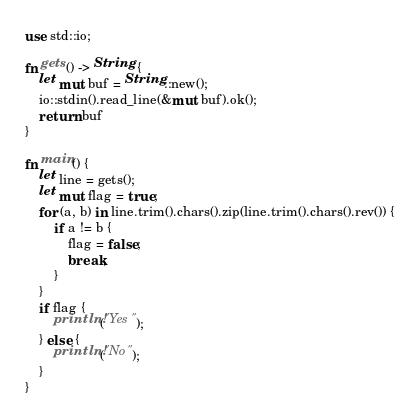<code> <loc_0><loc_0><loc_500><loc_500><_Rust_>use std::io;

fn gets() -> String {
    let mut buf = String::new();
    io::stdin().read_line(&mut buf).ok();
    return buf
}

fn main() {
    let line = gets();
    let mut flag = true;
    for (a, b) in line.trim().chars().zip(line.trim().chars().rev()) {
        if a != b {
            flag = false;
            break;
        }
    }
    if flag {
        println!("Yes");
    } else {
        println!("No");
    }
}
</code> 